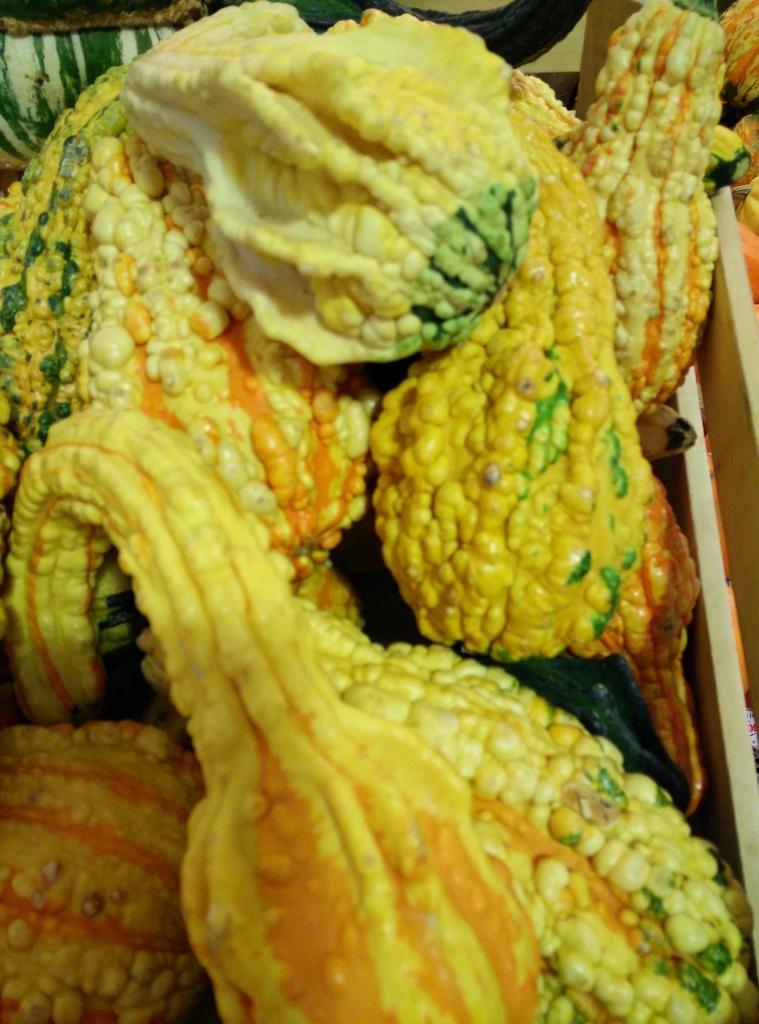Can you describe this image briefly? In this image there are gourds in the wooden box. 